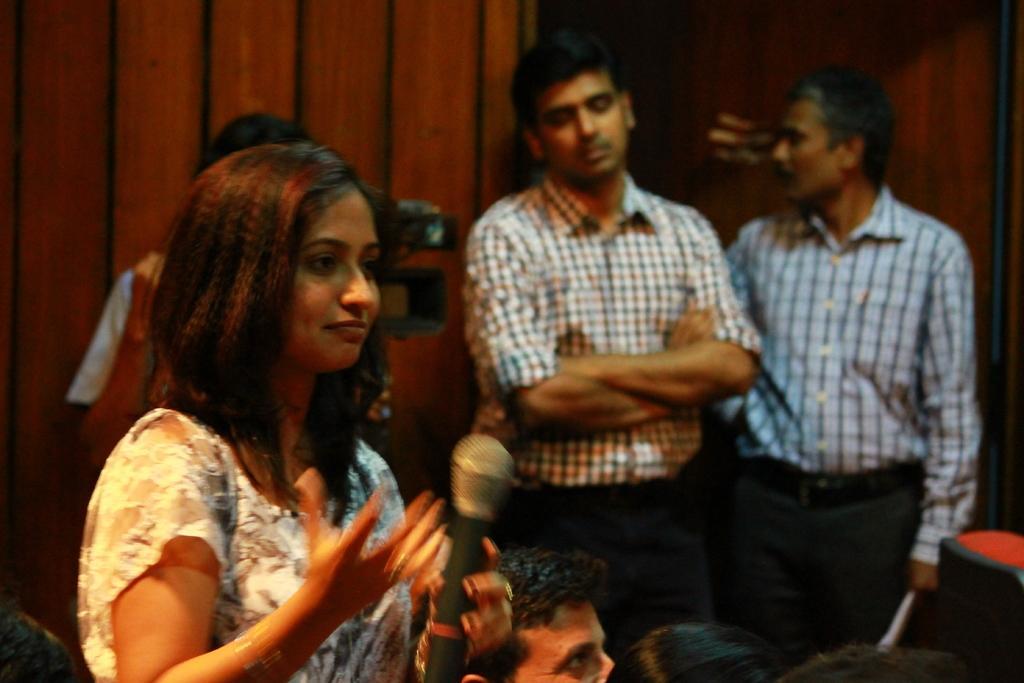Could you give a brief overview of what you see in this image? In this image there is a girl in the middle who is holding the mic. In the background there is a person holding the camera. On the right side there are two men standing on the ground. At the bottom there are few people. In the background there is a wooden wall. 